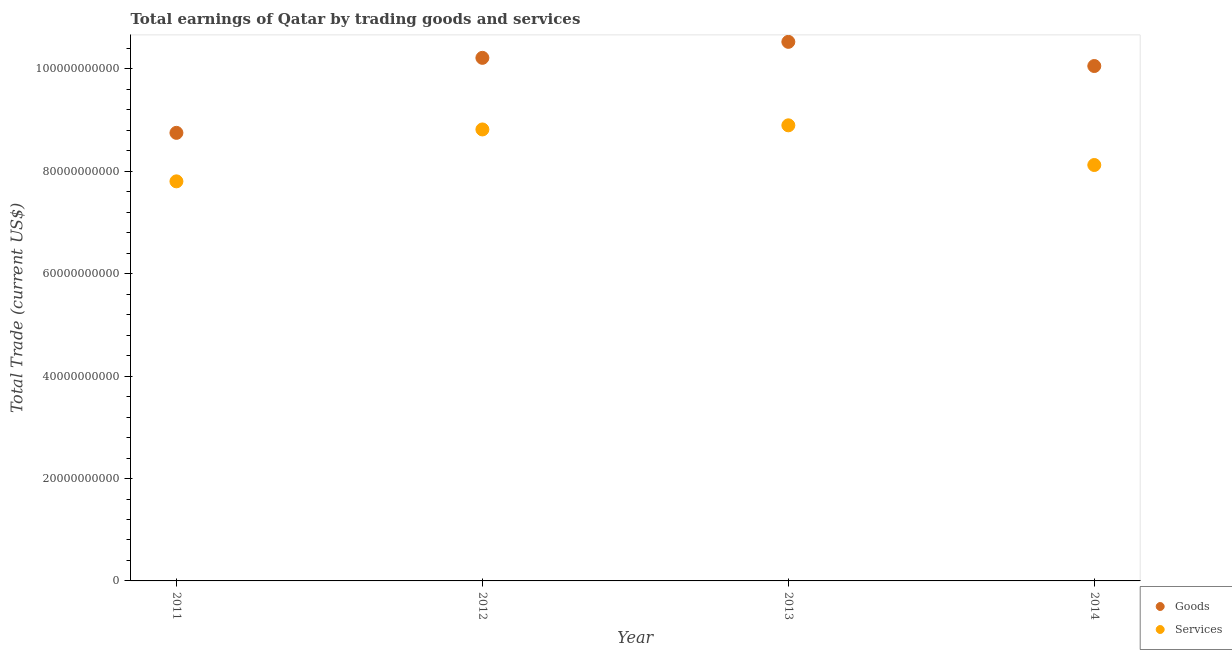How many different coloured dotlines are there?
Your response must be concise. 2. Is the number of dotlines equal to the number of legend labels?
Offer a very short reply. Yes. What is the amount earned by trading services in 2013?
Your answer should be compact. 8.90e+1. Across all years, what is the maximum amount earned by trading services?
Give a very brief answer. 8.90e+1. Across all years, what is the minimum amount earned by trading services?
Offer a terse response. 7.80e+1. What is the total amount earned by trading services in the graph?
Offer a very short reply. 3.36e+11. What is the difference between the amount earned by trading services in 2013 and that in 2014?
Make the answer very short. 7.75e+09. What is the difference between the amount earned by trading goods in 2011 and the amount earned by trading services in 2013?
Offer a terse response. -1.47e+09. What is the average amount earned by trading goods per year?
Give a very brief answer. 9.89e+1. In the year 2013, what is the difference between the amount earned by trading services and amount earned by trading goods?
Ensure brevity in your answer.  -1.63e+1. What is the ratio of the amount earned by trading goods in 2013 to that in 2014?
Keep it short and to the point. 1.05. Is the amount earned by trading services in 2012 less than that in 2013?
Your response must be concise. Yes. What is the difference between the highest and the second highest amount earned by trading services?
Provide a succinct answer. 8.06e+08. What is the difference between the highest and the lowest amount earned by trading goods?
Give a very brief answer. 1.78e+1. Is the sum of the amount earned by trading services in 2011 and 2013 greater than the maximum amount earned by trading goods across all years?
Your response must be concise. Yes. Is the amount earned by trading services strictly greater than the amount earned by trading goods over the years?
Give a very brief answer. No. Is the amount earned by trading goods strictly less than the amount earned by trading services over the years?
Give a very brief answer. No. How many dotlines are there?
Make the answer very short. 2. What is the difference between two consecutive major ticks on the Y-axis?
Keep it short and to the point. 2.00e+1. Are the values on the major ticks of Y-axis written in scientific E-notation?
Keep it short and to the point. No. Where does the legend appear in the graph?
Your response must be concise. Bottom right. What is the title of the graph?
Your answer should be compact. Total earnings of Qatar by trading goods and services. Does "Male population" appear as one of the legend labels in the graph?
Offer a terse response. No. What is the label or title of the Y-axis?
Ensure brevity in your answer.  Total Trade (current US$). What is the Total Trade (current US$) in Goods in 2011?
Your response must be concise. 8.75e+1. What is the Total Trade (current US$) of Services in 2011?
Keep it short and to the point. 7.80e+1. What is the Total Trade (current US$) in Goods in 2012?
Offer a terse response. 1.02e+11. What is the Total Trade (current US$) in Services in 2012?
Offer a terse response. 8.82e+1. What is the Total Trade (current US$) of Goods in 2013?
Your response must be concise. 1.05e+11. What is the Total Trade (current US$) in Services in 2013?
Your response must be concise. 8.90e+1. What is the Total Trade (current US$) of Goods in 2014?
Your answer should be very brief. 1.01e+11. What is the Total Trade (current US$) in Services in 2014?
Provide a succinct answer. 8.12e+1. Across all years, what is the maximum Total Trade (current US$) in Goods?
Your response must be concise. 1.05e+11. Across all years, what is the maximum Total Trade (current US$) of Services?
Give a very brief answer. 8.90e+1. Across all years, what is the minimum Total Trade (current US$) in Goods?
Provide a succinct answer. 8.75e+1. Across all years, what is the minimum Total Trade (current US$) in Services?
Offer a terse response. 7.80e+1. What is the total Total Trade (current US$) of Goods in the graph?
Offer a terse response. 3.96e+11. What is the total Total Trade (current US$) in Services in the graph?
Provide a succinct answer. 3.36e+11. What is the difference between the Total Trade (current US$) in Goods in 2011 and that in 2012?
Provide a short and direct response. -1.46e+1. What is the difference between the Total Trade (current US$) in Services in 2011 and that in 2012?
Keep it short and to the point. -1.01e+1. What is the difference between the Total Trade (current US$) of Goods in 2011 and that in 2013?
Provide a succinct answer. -1.78e+1. What is the difference between the Total Trade (current US$) of Services in 2011 and that in 2013?
Offer a very short reply. -1.09e+1. What is the difference between the Total Trade (current US$) in Goods in 2011 and that in 2014?
Offer a very short reply. -1.31e+1. What is the difference between the Total Trade (current US$) in Services in 2011 and that in 2014?
Your response must be concise. -3.19e+09. What is the difference between the Total Trade (current US$) in Goods in 2012 and that in 2013?
Your answer should be very brief. -3.13e+09. What is the difference between the Total Trade (current US$) of Services in 2012 and that in 2013?
Your answer should be very brief. -8.06e+08. What is the difference between the Total Trade (current US$) of Goods in 2012 and that in 2014?
Make the answer very short. 1.60e+09. What is the difference between the Total Trade (current US$) in Services in 2012 and that in 2014?
Provide a short and direct response. 6.94e+09. What is the difference between the Total Trade (current US$) of Goods in 2013 and that in 2014?
Ensure brevity in your answer.  4.72e+09. What is the difference between the Total Trade (current US$) in Services in 2013 and that in 2014?
Provide a short and direct response. 7.75e+09. What is the difference between the Total Trade (current US$) in Goods in 2011 and the Total Trade (current US$) in Services in 2012?
Your answer should be very brief. -6.64e+08. What is the difference between the Total Trade (current US$) in Goods in 2011 and the Total Trade (current US$) in Services in 2013?
Make the answer very short. -1.47e+09. What is the difference between the Total Trade (current US$) in Goods in 2011 and the Total Trade (current US$) in Services in 2014?
Make the answer very short. 6.28e+09. What is the difference between the Total Trade (current US$) in Goods in 2012 and the Total Trade (current US$) in Services in 2013?
Ensure brevity in your answer.  1.32e+1. What is the difference between the Total Trade (current US$) of Goods in 2012 and the Total Trade (current US$) of Services in 2014?
Offer a very short reply. 2.09e+1. What is the difference between the Total Trade (current US$) in Goods in 2013 and the Total Trade (current US$) in Services in 2014?
Make the answer very short. 2.41e+1. What is the average Total Trade (current US$) in Goods per year?
Keep it short and to the point. 9.89e+1. What is the average Total Trade (current US$) of Services per year?
Make the answer very short. 8.41e+1. In the year 2011, what is the difference between the Total Trade (current US$) in Goods and Total Trade (current US$) in Services?
Provide a succinct answer. 9.47e+09. In the year 2012, what is the difference between the Total Trade (current US$) of Goods and Total Trade (current US$) of Services?
Keep it short and to the point. 1.40e+1. In the year 2013, what is the difference between the Total Trade (current US$) in Goods and Total Trade (current US$) in Services?
Ensure brevity in your answer.  1.63e+1. In the year 2014, what is the difference between the Total Trade (current US$) in Goods and Total Trade (current US$) in Services?
Your response must be concise. 1.93e+1. What is the ratio of the Total Trade (current US$) of Goods in 2011 to that in 2012?
Provide a short and direct response. 0.86. What is the ratio of the Total Trade (current US$) in Services in 2011 to that in 2012?
Keep it short and to the point. 0.89. What is the ratio of the Total Trade (current US$) in Goods in 2011 to that in 2013?
Your answer should be very brief. 0.83. What is the ratio of the Total Trade (current US$) in Services in 2011 to that in 2013?
Your answer should be compact. 0.88. What is the ratio of the Total Trade (current US$) of Goods in 2011 to that in 2014?
Keep it short and to the point. 0.87. What is the ratio of the Total Trade (current US$) of Services in 2011 to that in 2014?
Keep it short and to the point. 0.96. What is the ratio of the Total Trade (current US$) in Goods in 2012 to that in 2013?
Keep it short and to the point. 0.97. What is the ratio of the Total Trade (current US$) of Services in 2012 to that in 2013?
Provide a succinct answer. 0.99. What is the ratio of the Total Trade (current US$) in Goods in 2012 to that in 2014?
Your answer should be compact. 1.02. What is the ratio of the Total Trade (current US$) of Services in 2012 to that in 2014?
Ensure brevity in your answer.  1.09. What is the ratio of the Total Trade (current US$) in Goods in 2013 to that in 2014?
Your answer should be compact. 1.05. What is the ratio of the Total Trade (current US$) of Services in 2013 to that in 2014?
Your answer should be very brief. 1.1. What is the difference between the highest and the second highest Total Trade (current US$) in Goods?
Offer a very short reply. 3.13e+09. What is the difference between the highest and the second highest Total Trade (current US$) in Services?
Your response must be concise. 8.06e+08. What is the difference between the highest and the lowest Total Trade (current US$) in Goods?
Your answer should be very brief. 1.78e+1. What is the difference between the highest and the lowest Total Trade (current US$) in Services?
Offer a terse response. 1.09e+1. 